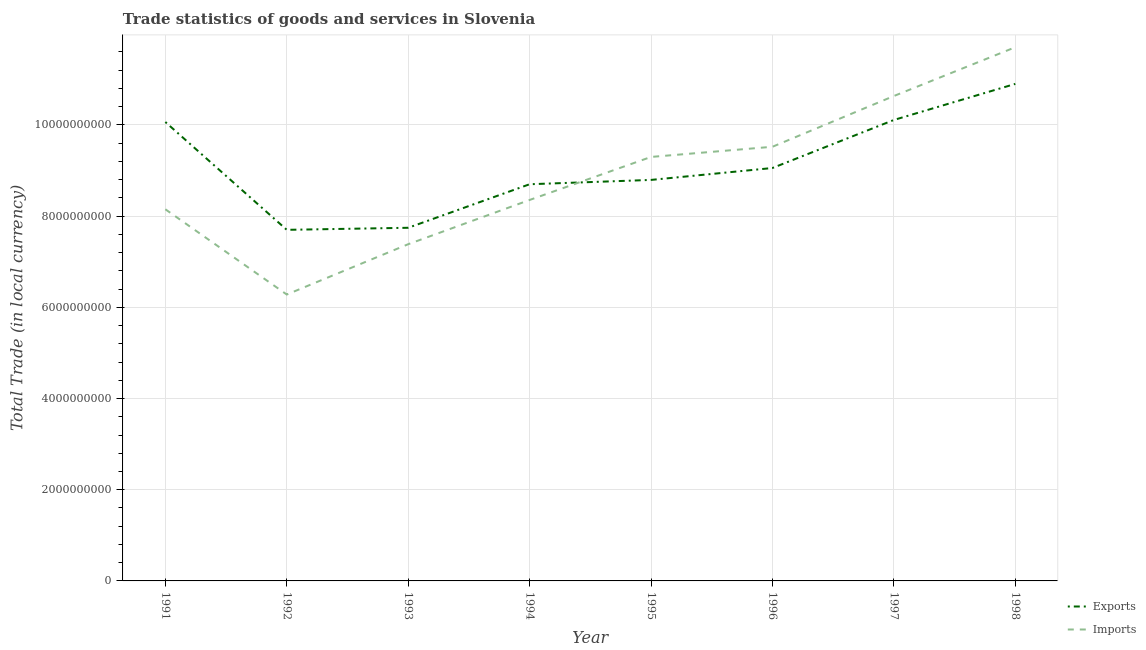How many different coloured lines are there?
Provide a succinct answer. 2. What is the export of goods and services in 1995?
Your answer should be compact. 8.79e+09. Across all years, what is the maximum imports of goods and services?
Your answer should be compact. 1.17e+1. Across all years, what is the minimum export of goods and services?
Give a very brief answer. 7.70e+09. What is the total imports of goods and services in the graph?
Make the answer very short. 7.13e+1. What is the difference between the export of goods and services in 1993 and that in 1996?
Offer a terse response. -1.31e+09. What is the difference between the imports of goods and services in 1997 and the export of goods and services in 1998?
Your answer should be compact. -2.66e+08. What is the average imports of goods and services per year?
Your answer should be very brief. 8.92e+09. In the year 1991, what is the difference between the export of goods and services and imports of goods and services?
Make the answer very short. 1.91e+09. In how many years, is the imports of goods and services greater than 9200000000 LCU?
Offer a very short reply. 4. What is the ratio of the export of goods and services in 1991 to that in 1994?
Provide a short and direct response. 1.16. Is the export of goods and services in 1992 less than that in 1998?
Keep it short and to the point. Yes. What is the difference between the highest and the second highest imports of goods and services?
Make the answer very short. 1.07e+09. What is the difference between the highest and the lowest export of goods and services?
Your answer should be compact. 3.20e+09. In how many years, is the export of goods and services greater than the average export of goods and services taken over all years?
Offer a terse response. 3. Is the sum of the imports of goods and services in 1991 and 1994 greater than the maximum export of goods and services across all years?
Your answer should be compact. Yes. Is the export of goods and services strictly less than the imports of goods and services over the years?
Your answer should be very brief. No. How many years are there in the graph?
Offer a very short reply. 8. What is the difference between two consecutive major ticks on the Y-axis?
Make the answer very short. 2.00e+09. Does the graph contain any zero values?
Give a very brief answer. No. Does the graph contain grids?
Your answer should be very brief. Yes. Where does the legend appear in the graph?
Your answer should be compact. Bottom right. How are the legend labels stacked?
Your answer should be very brief. Vertical. What is the title of the graph?
Your answer should be very brief. Trade statistics of goods and services in Slovenia. Does "Female entrants" appear as one of the legend labels in the graph?
Your response must be concise. No. What is the label or title of the Y-axis?
Give a very brief answer. Total Trade (in local currency). What is the Total Trade (in local currency) of Exports in 1991?
Your response must be concise. 1.01e+1. What is the Total Trade (in local currency) of Imports in 1991?
Your answer should be compact. 8.15e+09. What is the Total Trade (in local currency) of Exports in 1992?
Your response must be concise. 7.70e+09. What is the Total Trade (in local currency) of Imports in 1992?
Your answer should be very brief. 6.28e+09. What is the Total Trade (in local currency) in Exports in 1993?
Provide a succinct answer. 7.74e+09. What is the Total Trade (in local currency) in Imports in 1993?
Ensure brevity in your answer.  7.38e+09. What is the Total Trade (in local currency) of Exports in 1994?
Your response must be concise. 8.70e+09. What is the Total Trade (in local currency) in Imports in 1994?
Provide a succinct answer. 8.35e+09. What is the Total Trade (in local currency) in Exports in 1995?
Your response must be concise. 8.79e+09. What is the Total Trade (in local currency) of Imports in 1995?
Provide a short and direct response. 9.30e+09. What is the Total Trade (in local currency) of Exports in 1996?
Provide a succinct answer. 9.06e+09. What is the Total Trade (in local currency) of Imports in 1996?
Your response must be concise. 9.52e+09. What is the Total Trade (in local currency) of Exports in 1997?
Ensure brevity in your answer.  1.01e+1. What is the Total Trade (in local currency) in Imports in 1997?
Offer a very short reply. 1.06e+1. What is the Total Trade (in local currency) of Exports in 1998?
Your answer should be very brief. 1.09e+1. What is the Total Trade (in local currency) of Imports in 1998?
Offer a terse response. 1.17e+1. Across all years, what is the maximum Total Trade (in local currency) in Exports?
Keep it short and to the point. 1.09e+1. Across all years, what is the maximum Total Trade (in local currency) in Imports?
Your response must be concise. 1.17e+1. Across all years, what is the minimum Total Trade (in local currency) in Exports?
Offer a very short reply. 7.70e+09. Across all years, what is the minimum Total Trade (in local currency) in Imports?
Your answer should be compact. 6.28e+09. What is the total Total Trade (in local currency) in Exports in the graph?
Offer a very short reply. 7.31e+1. What is the total Total Trade (in local currency) in Imports in the graph?
Your answer should be very brief. 7.13e+1. What is the difference between the Total Trade (in local currency) of Exports in 1991 and that in 1992?
Your answer should be very brief. 2.36e+09. What is the difference between the Total Trade (in local currency) in Imports in 1991 and that in 1992?
Offer a very short reply. 1.87e+09. What is the difference between the Total Trade (in local currency) in Exports in 1991 and that in 1993?
Provide a succinct answer. 2.32e+09. What is the difference between the Total Trade (in local currency) of Imports in 1991 and that in 1993?
Make the answer very short. 7.66e+08. What is the difference between the Total Trade (in local currency) in Exports in 1991 and that in 1994?
Give a very brief answer. 1.36e+09. What is the difference between the Total Trade (in local currency) in Imports in 1991 and that in 1994?
Make the answer very short. -2.04e+08. What is the difference between the Total Trade (in local currency) in Exports in 1991 and that in 1995?
Make the answer very short. 1.27e+09. What is the difference between the Total Trade (in local currency) of Imports in 1991 and that in 1995?
Make the answer very short. -1.15e+09. What is the difference between the Total Trade (in local currency) of Exports in 1991 and that in 1996?
Offer a very short reply. 1.01e+09. What is the difference between the Total Trade (in local currency) in Imports in 1991 and that in 1996?
Provide a short and direct response. -1.37e+09. What is the difference between the Total Trade (in local currency) of Exports in 1991 and that in 1997?
Provide a short and direct response. -4.51e+07. What is the difference between the Total Trade (in local currency) in Imports in 1991 and that in 1997?
Your response must be concise. -2.48e+09. What is the difference between the Total Trade (in local currency) in Exports in 1991 and that in 1998?
Give a very brief answer. -8.36e+08. What is the difference between the Total Trade (in local currency) in Imports in 1991 and that in 1998?
Provide a short and direct response. -3.55e+09. What is the difference between the Total Trade (in local currency) in Exports in 1992 and that in 1993?
Your response must be concise. -4.52e+07. What is the difference between the Total Trade (in local currency) in Imports in 1992 and that in 1993?
Make the answer very short. -1.10e+09. What is the difference between the Total Trade (in local currency) in Exports in 1992 and that in 1994?
Your answer should be compact. -1.00e+09. What is the difference between the Total Trade (in local currency) of Imports in 1992 and that in 1994?
Offer a very short reply. -2.07e+09. What is the difference between the Total Trade (in local currency) of Exports in 1992 and that in 1995?
Provide a short and direct response. -1.09e+09. What is the difference between the Total Trade (in local currency) of Imports in 1992 and that in 1995?
Ensure brevity in your answer.  -3.02e+09. What is the difference between the Total Trade (in local currency) of Exports in 1992 and that in 1996?
Give a very brief answer. -1.36e+09. What is the difference between the Total Trade (in local currency) in Imports in 1992 and that in 1996?
Your answer should be very brief. -3.24e+09. What is the difference between the Total Trade (in local currency) of Exports in 1992 and that in 1997?
Make the answer very short. -2.41e+09. What is the difference between the Total Trade (in local currency) in Imports in 1992 and that in 1997?
Provide a succinct answer. -4.35e+09. What is the difference between the Total Trade (in local currency) in Exports in 1992 and that in 1998?
Your response must be concise. -3.20e+09. What is the difference between the Total Trade (in local currency) in Imports in 1992 and that in 1998?
Keep it short and to the point. -5.42e+09. What is the difference between the Total Trade (in local currency) of Exports in 1993 and that in 1994?
Offer a very short reply. -9.55e+08. What is the difference between the Total Trade (in local currency) in Imports in 1993 and that in 1994?
Your response must be concise. -9.70e+08. What is the difference between the Total Trade (in local currency) in Exports in 1993 and that in 1995?
Offer a terse response. -1.05e+09. What is the difference between the Total Trade (in local currency) of Imports in 1993 and that in 1995?
Give a very brief answer. -1.91e+09. What is the difference between the Total Trade (in local currency) in Exports in 1993 and that in 1996?
Offer a terse response. -1.31e+09. What is the difference between the Total Trade (in local currency) in Imports in 1993 and that in 1996?
Provide a succinct answer. -2.14e+09. What is the difference between the Total Trade (in local currency) of Exports in 1993 and that in 1997?
Your response must be concise. -2.36e+09. What is the difference between the Total Trade (in local currency) in Imports in 1993 and that in 1997?
Offer a terse response. -3.25e+09. What is the difference between the Total Trade (in local currency) of Exports in 1993 and that in 1998?
Your response must be concise. -3.16e+09. What is the difference between the Total Trade (in local currency) in Imports in 1993 and that in 1998?
Offer a very short reply. -4.32e+09. What is the difference between the Total Trade (in local currency) of Exports in 1994 and that in 1995?
Offer a very short reply. -9.48e+07. What is the difference between the Total Trade (in local currency) in Imports in 1994 and that in 1995?
Keep it short and to the point. -9.44e+08. What is the difference between the Total Trade (in local currency) in Exports in 1994 and that in 1996?
Provide a succinct answer. -3.56e+08. What is the difference between the Total Trade (in local currency) of Imports in 1994 and that in 1996?
Give a very brief answer. -1.17e+09. What is the difference between the Total Trade (in local currency) of Exports in 1994 and that in 1997?
Your answer should be very brief. -1.41e+09. What is the difference between the Total Trade (in local currency) in Imports in 1994 and that in 1997?
Make the answer very short. -2.28e+09. What is the difference between the Total Trade (in local currency) in Exports in 1994 and that in 1998?
Your answer should be compact. -2.20e+09. What is the difference between the Total Trade (in local currency) of Imports in 1994 and that in 1998?
Make the answer very short. -3.35e+09. What is the difference between the Total Trade (in local currency) of Exports in 1995 and that in 1996?
Your answer should be very brief. -2.61e+08. What is the difference between the Total Trade (in local currency) in Imports in 1995 and that in 1996?
Your response must be concise. -2.23e+08. What is the difference between the Total Trade (in local currency) in Exports in 1995 and that in 1997?
Your response must be concise. -1.31e+09. What is the difference between the Total Trade (in local currency) in Imports in 1995 and that in 1997?
Your response must be concise. -1.34e+09. What is the difference between the Total Trade (in local currency) of Exports in 1995 and that in 1998?
Ensure brevity in your answer.  -2.11e+09. What is the difference between the Total Trade (in local currency) of Imports in 1995 and that in 1998?
Make the answer very short. -2.41e+09. What is the difference between the Total Trade (in local currency) in Exports in 1996 and that in 1997?
Your response must be concise. -1.05e+09. What is the difference between the Total Trade (in local currency) in Imports in 1996 and that in 1997?
Provide a succinct answer. -1.11e+09. What is the difference between the Total Trade (in local currency) of Exports in 1996 and that in 1998?
Offer a terse response. -1.84e+09. What is the difference between the Total Trade (in local currency) in Imports in 1996 and that in 1998?
Give a very brief answer. -2.18e+09. What is the difference between the Total Trade (in local currency) in Exports in 1997 and that in 1998?
Provide a succinct answer. -7.91e+08. What is the difference between the Total Trade (in local currency) in Imports in 1997 and that in 1998?
Keep it short and to the point. -1.07e+09. What is the difference between the Total Trade (in local currency) in Exports in 1991 and the Total Trade (in local currency) in Imports in 1992?
Your answer should be very brief. 3.78e+09. What is the difference between the Total Trade (in local currency) in Exports in 1991 and the Total Trade (in local currency) in Imports in 1993?
Make the answer very short. 2.68e+09. What is the difference between the Total Trade (in local currency) of Exports in 1991 and the Total Trade (in local currency) of Imports in 1994?
Ensure brevity in your answer.  1.71e+09. What is the difference between the Total Trade (in local currency) of Exports in 1991 and the Total Trade (in local currency) of Imports in 1995?
Offer a terse response. 7.66e+08. What is the difference between the Total Trade (in local currency) in Exports in 1991 and the Total Trade (in local currency) in Imports in 1996?
Ensure brevity in your answer.  5.43e+08. What is the difference between the Total Trade (in local currency) of Exports in 1991 and the Total Trade (in local currency) of Imports in 1997?
Your answer should be compact. -5.70e+08. What is the difference between the Total Trade (in local currency) of Exports in 1991 and the Total Trade (in local currency) of Imports in 1998?
Your answer should be compact. -1.64e+09. What is the difference between the Total Trade (in local currency) in Exports in 1992 and the Total Trade (in local currency) in Imports in 1993?
Ensure brevity in your answer.  3.15e+08. What is the difference between the Total Trade (in local currency) in Exports in 1992 and the Total Trade (in local currency) in Imports in 1994?
Keep it short and to the point. -6.55e+08. What is the difference between the Total Trade (in local currency) of Exports in 1992 and the Total Trade (in local currency) of Imports in 1995?
Provide a succinct answer. -1.60e+09. What is the difference between the Total Trade (in local currency) in Exports in 1992 and the Total Trade (in local currency) in Imports in 1996?
Your answer should be compact. -1.82e+09. What is the difference between the Total Trade (in local currency) of Exports in 1992 and the Total Trade (in local currency) of Imports in 1997?
Your answer should be compact. -2.93e+09. What is the difference between the Total Trade (in local currency) of Exports in 1992 and the Total Trade (in local currency) of Imports in 1998?
Provide a succinct answer. -4.00e+09. What is the difference between the Total Trade (in local currency) of Exports in 1993 and the Total Trade (in local currency) of Imports in 1994?
Offer a very short reply. -6.10e+08. What is the difference between the Total Trade (in local currency) in Exports in 1993 and the Total Trade (in local currency) in Imports in 1995?
Provide a succinct answer. -1.55e+09. What is the difference between the Total Trade (in local currency) of Exports in 1993 and the Total Trade (in local currency) of Imports in 1996?
Keep it short and to the point. -1.78e+09. What is the difference between the Total Trade (in local currency) in Exports in 1993 and the Total Trade (in local currency) in Imports in 1997?
Offer a terse response. -2.89e+09. What is the difference between the Total Trade (in local currency) of Exports in 1993 and the Total Trade (in local currency) of Imports in 1998?
Keep it short and to the point. -3.96e+09. What is the difference between the Total Trade (in local currency) of Exports in 1994 and the Total Trade (in local currency) of Imports in 1995?
Offer a very short reply. -5.99e+08. What is the difference between the Total Trade (in local currency) in Exports in 1994 and the Total Trade (in local currency) in Imports in 1996?
Keep it short and to the point. -8.22e+08. What is the difference between the Total Trade (in local currency) in Exports in 1994 and the Total Trade (in local currency) in Imports in 1997?
Offer a very short reply. -1.93e+09. What is the difference between the Total Trade (in local currency) in Exports in 1994 and the Total Trade (in local currency) in Imports in 1998?
Your response must be concise. -3.00e+09. What is the difference between the Total Trade (in local currency) of Exports in 1995 and the Total Trade (in local currency) of Imports in 1996?
Ensure brevity in your answer.  -7.27e+08. What is the difference between the Total Trade (in local currency) in Exports in 1995 and the Total Trade (in local currency) in Imports in 1997?
Ensure brevity in your answer.  -1.84e+09. What is the difference between the Total Trade (in local currency) of Exports in 1995 and the Total Trade (in local currency) of Imports in 1998?
Your answer should be very brief. -2.91e+09. What is the difference between the Total Trade (in local currency) of Exports in 1996 and the Total Trade (in local currency) of Imports in 1997?
Your answer should be very brief. -1.58e+09. What is the difference between the Total Trade (in local currency) of Exports in 1996 and the Total Trade (in local currency) of Imports in 1998?
Provide a short and direct response. -2.65e+09. What is the difference between the Total Trade (in local currency) in Exports in 1997 and the Total Trade (in local currency) in Imports in 1998?
Make the answer very short. -1.59e+09. What is the average Total Trade (in local currency) of Exports per year?
Provide a succinct answer. 9.13e+09. What is the average Total Trade (in local currency) of Imports per year?
Your answer should be very brief. 8.92e+09. In the year 1991, what is the difference between the Total Trade (in local currency) in Exports and Total Trade (in local currency) in Imports?
Give a very brief answer. 1.91e+09. In the year 1992, what is the difference between the Total Trade (in local currency) of Exports and Total Trade (in local currency) of Imports?
Provide a short and direct response. 1.42e+09. In the year 1993, what is the difference between the Total Trade (in local currency) of Exports and Total Trade (in local currency) of Imports?
Keep it short and to the point. 3.60e+08. In the year 1994, what is the difference between the Total Trade (in local currency) in Exports and Total Trade (in local currency) in Imports?
Offer a terse response. 3.45e+08. In the year 1995, what is the difference between the Total Trade (in local currency) in Exports and Total Trade (in local currency) in Imports?
Offer a terse response. -5.04e+08. In the year 1996, what is the difference between the Total Trade (in local currency) in Exports and Total Trade (in local currency) in Imports?
Offer a terse response. -4.66e+08. In the year 1997, what is the difference between the Total Trade (in local currency) in Exports and Total Trade (in local currency) in Imports?
Make the answer very short. -5.25e+08. In the year 1998, what is the difference between the Total Trade (in local currency) in Exports and Total Trade (in local currency) in Imports?
Keep it short and to the point. -8.04e+08. What is the ratio of the Total Trade (in local currency) in Exports in 1991 to that in 1992?
Make the answer very short. 1.31. What is the ratio of the Total Trade (in local currency) in Imports in 1991 to that in 1992?
Offer a very short reply. 1.3. What is the ratio of the Total Trade (in local currency) in Exports in 1991 to that in 1993?
Make the answer very short. 1.3. What is the ratio of the Total Trade (in local currency) of Imports in 1991 to that in 1993?
Give a very brief answer. 1.1. What is the ratio of the Total Trade (in local currency) in Exports in 1991 to that in 1994?
Give a very brief answer. 1.16. What is the ratio of the Total Trade (in local currency) in Imports in 1991 to that in 1994?
Offer a very short reply. 0.98. What is the ratio of the Total Trade (in local currency) in Exports in 1991 to that in 1995?
Give a very brief answer. 1.14. What is the ratio of the Total Trade (in local currency) in Imports in 1991 to that in 1995?
Keep it short and to the point. 0.88. What is the ratio of the Total Trade (in local currency) in Exports in 1991 to that in 1996?
Your response must be concise. 1.11. What is the ratio of the Total Trade (in local currency) in Imports in 1991 to that in 1996?
Your answer should be compact. 0.86. What is the ratio of the Total Trade (in local currency) of Exports in 1991 to that in 1997?
Keep it short and to the point. 1. What is the ratio of the Total Trade (in local currency) of Imports in 1991 to that in 1997?
Your answer should be very brief. 0.77. What is the ratio of the Total Trade (in local currency) of Exports in 1991 to that in 1998?
Your answer should be compact. 0.92. What is the ratio of the Total Trade (in local currency) in Imports in 1991 to that in 1998?
Keep it short and to the point. 0.7. What is the ratio of the Total Trade (in local currency) of Imports in 1992 to that in 1993?
Ensure brevity in your answer.  0.85. What is the ratio of the Total Trade (in local currency) of Exports in 1992 to that in 1994?
Ensure brevity in your answer.  0.89. What is the ratio of the Total Trade (in local currency) of Imports in 1992 to that in 1994?
Provide a short and direct response. 0.75. What is the ratio of the Total Trade (in local currency) in Exports in 1992 to that in 1995?
Offer a very short reply. 0.88. What is the ratio of the Total Trade (in local currency) of Imports in 1992 to that in 1995?
Your answer should be very brief. 0.68. What is the ratio of the Total Trade (in local currency) of Exports in 1992 to that in 1996?
Offer a terse response. 0.85. What is the ratio of the Total Trade (in local currency) in Imports in 1992 to that in 1996?
Keep it short and to the point. 0.66. What is the ratio of the Total Trade (in local currency) of Exports in 1992 to that in 1997?
Keep it short and to the point. 0.76. What is the ratio of the Total Trade (in local currency) in Imports in 1992 to that in 1997?
Offer a terse response. 0.59. What is the ratio of the Total Trade (in local currency) of Exports in 1992 to that in 1998?
Keep it short and to the point. 0.71. What is the ratio of the Total Trade (in local currency) in Imports in 1992 to that in 1998?
Offer a very short reply. 0.54. What is the ratio of the Total Trade (in local currency) in Exports in 1993 to that in 1994?
Offer a very short reply. 0.89. What is the ratio of the Total Trade (in local currency) of Imports in 1993 to that in 1994?
Provide a succinct answer. 0.88. What is the ratio of the Total Trade (in local currency) of Exports in 1993 to that in 1995?
Offer a very short reply. 0.88. What is the ratio of the Total Trade (in local currency) of Imports in 1993 to that in 1995?
Your answer should be very brief. 0.79. What is the ratio of the Total Trade (in local currency) of Exports in 1993 to that in 1996?
Offer a terse response. 0.86. What is the ratio of the Total Trade (in local currency) of Imports in 1993 to that in 1996?
Your answer should be compact. 0.78. What is the ratio of the Total Trade (in local currency) in Exports in 1993 to that in 1997?
Ensure brevity in your answer.  0.77. What is the ratio of the Total Trade (in local currency) of Imports in 1993 to that in 1997?
Provide a short and direct response. 0.69. What is the ratio of the Total Trade (in local currency) in Exports in 1993 to that in 1998?
Ensure brevity in your answer.  0.71. What is the ratio of the Total Trade (in local currency) in Imports in 1993 to that in 1998?
Offer a terse response. 0.63. What is the ratio of the Total Trade (in local currency) of Imports in 1994 to that in 1995?
Ensure brevity in your answer.  0.9. What is the ratio of the Total Trade (in local currency) in Exports in 1994 to that in 1996?
Your response must be concise. 0.96. What is the ratio of the Total Trade (in local currency) of Imports in 1994 to that in 1996?
Provide a succinct answer. 0.88. What is the ratio of the Total Trade (in local currency) in Exports in 1994 to that in 1997?
Offer a terse response. 0.86. What is the ratio of the Total Trade (in local currency) in Imports in 1994 to that in 1997?
Offer a terse response. 0.79. What is the ratio of the Total Trade (in local currency) of Exports in 1994 to that in 1998?
Offer a very short reply. 0.8. What is the ratio of the Total Trade (in local currency) in Imports in 1994 to that in 1998?
Provide a succinct answer. 0.71. What is the ratio of the Total Trade (in local currency) of Exports in 1995 to that in 1996?
Give a very brief answer. 0.97. What is the ratio of the Total Trade (in local currency) in Imports in 1995 to that in 1996?
Keep it short and to the point. 0.98. What is the ratio of the Total Trade (in local currency) in Exports in 1995 to that in 1997?
Provide a short and direct response. 0.87. What is the ratio of the Total Trade (in local currency) of Imports in 1995 to that in 1997?
Make the answer very short. 0.87. What is the ratio of the Total Trade (in local currency) of Exports in 1995 to that in 1998?
Make the answer very short. 0.81. What is the ratio of the Total Trade (in local currency) in Imports in 1995 to that in 1998?
Your answer should be very brief. 0.79. What is the ratio of the Total Trade (in local currency) in Exports in 1996 to that in 1997?
Give a very brief answer. 0.9. What is the ratio of the Total Trade (in local currency) of Imports in 1996 to that in 1997?
Give a very brief answer. 0.9. What is the ratio of the Total Trade (in local currency) in Exports in 1996 to that in 1998?
Your answer should be very brief. 0.83. What is the ratio of the Total Trade (in local currency) of Imports in 1996 to that in 1998?
Your answer should be compact. 0.81. What is the ratio of the Total Trade (in local currency) of Exports in 1997 to that in 1998?
Offer a terse response. 0.93. What is the ratio of the Total Trade (in local currency) in Imports in 1997 to that in 1998?
Your response must be concise. 0.91. What is the difference between the highest and the second highest Total Trade (in local currency) in Exports?
Keep it short and to the point. 7.91e+08. What is the difference between the highest and the second highest Total Trade (in local currency) in Imports?
Ensure brevity in your answer.  1.07e+09. What is the difference between the highest and the lowest Total Trade (in local currency) of Exports?
Your answer should be very brief. 3.20e+09. What is the difference between the highest and the lowest Total Trade (in local currency) of Imports?
Keep it short and to the point. 5.42e+09. 